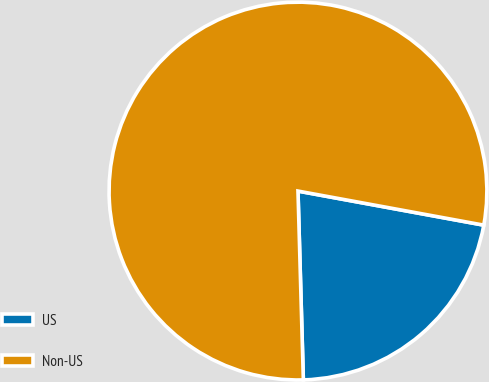<chart> <loc_0><loc_0><loc_500><loc_500><pie_chart><fcel>US<fcel>Non-US<nl><fcel>21.66%<fcel>78.34%<nl></chart> 